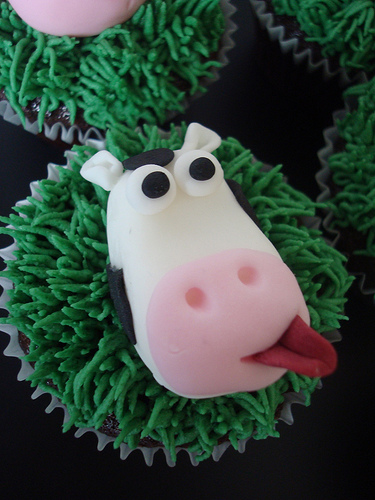<image>
Can you confirm if the cow is on the wrapper? Yes. Looking at the image, I can see the cow is positioned on top of the wrapper, with the wrapper providing support. Is there a tongue next to the grass? Yes. The tongue is positioned adjacent to the grass, located nearby in the same general area. Is the tounge in front of the pop? Yes. The tounge is positioned in front of the pop, appearing closer to the camera viewpoint. 